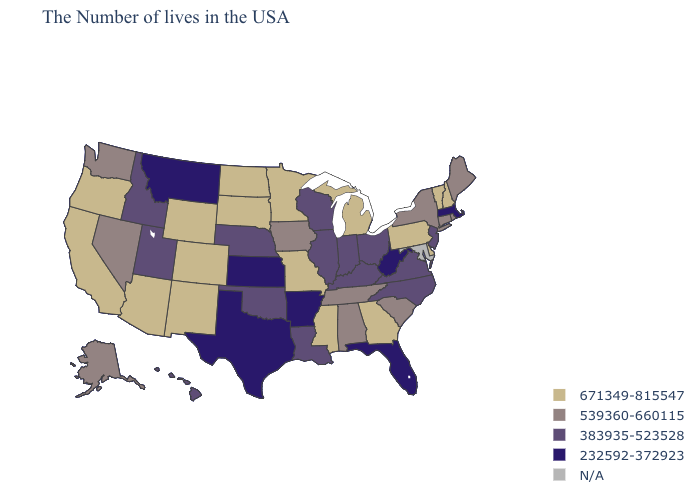Name the states that have a value in the range 539360-660115?
Write a very short answer. Maine, Rhode Island, Connecticut, New York, South Carolina, Alabama, Tennessee, Iowa, Nevada, Washington, Alaska. Name the states that have a value in the range 539360-660115?
Keep it brief. Maine, Rhode Island, Connecticut, New York, South Carolina, Alabama, Tennessee, Iowa, Nevada, Washington, Alaska. What is the lowest value in the USA?
Answer briefly. 232592-372923. Name the states that have a value in the range 671349-815547?
Short answer required. New Hampshire, Vermont, Delaware, Pennsylvania, Georgia, Michigan, Mississippi, Missouri, Minnesota, South Dakota, North Dakota, Wyoming, Colorado, New Mexico, Arizona, California, Oregon. Name the states that have a value in the range 671349-815547?
Short answer required. New Hampshire, Vermont, Delaware, Pennsylvania, Georgia, Michigan, Mississippi, Missouri, Minnesota, South Dakota, North Dakota, Wyoming, Colorado, New Mexico, Arizona, California, Oregon. Which states have the lowest value in the USA?
Answer briefly. Massachusetts, West Virginia, Florida, Arkansas, Kansas, Texas, Montana. What is the value of West Virginia?
Quick response, please. 232592-372923. Does Massachusetts have the lowest value in the Northeast?
Be succinct. Yes. What is the highest value in the Northeast ?
Short answer required. 671349-815547. What is the value of Arkansas?
Keep it brief. 232592-372923. What is the value of Missouri?
Quick response, please. 671349-815547. What is the value of Georgia?
Quick response, please. 671349-815547. What is the value of Arizona?
Write a very short answer. 671349-815547. What is the lowest value in the USA?
Write a very short answer. 232592-372923. 